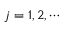<formula> <loc_0><loc_0><loc_500><loc_500>j = 1 , 2 , \cdots</formula> 